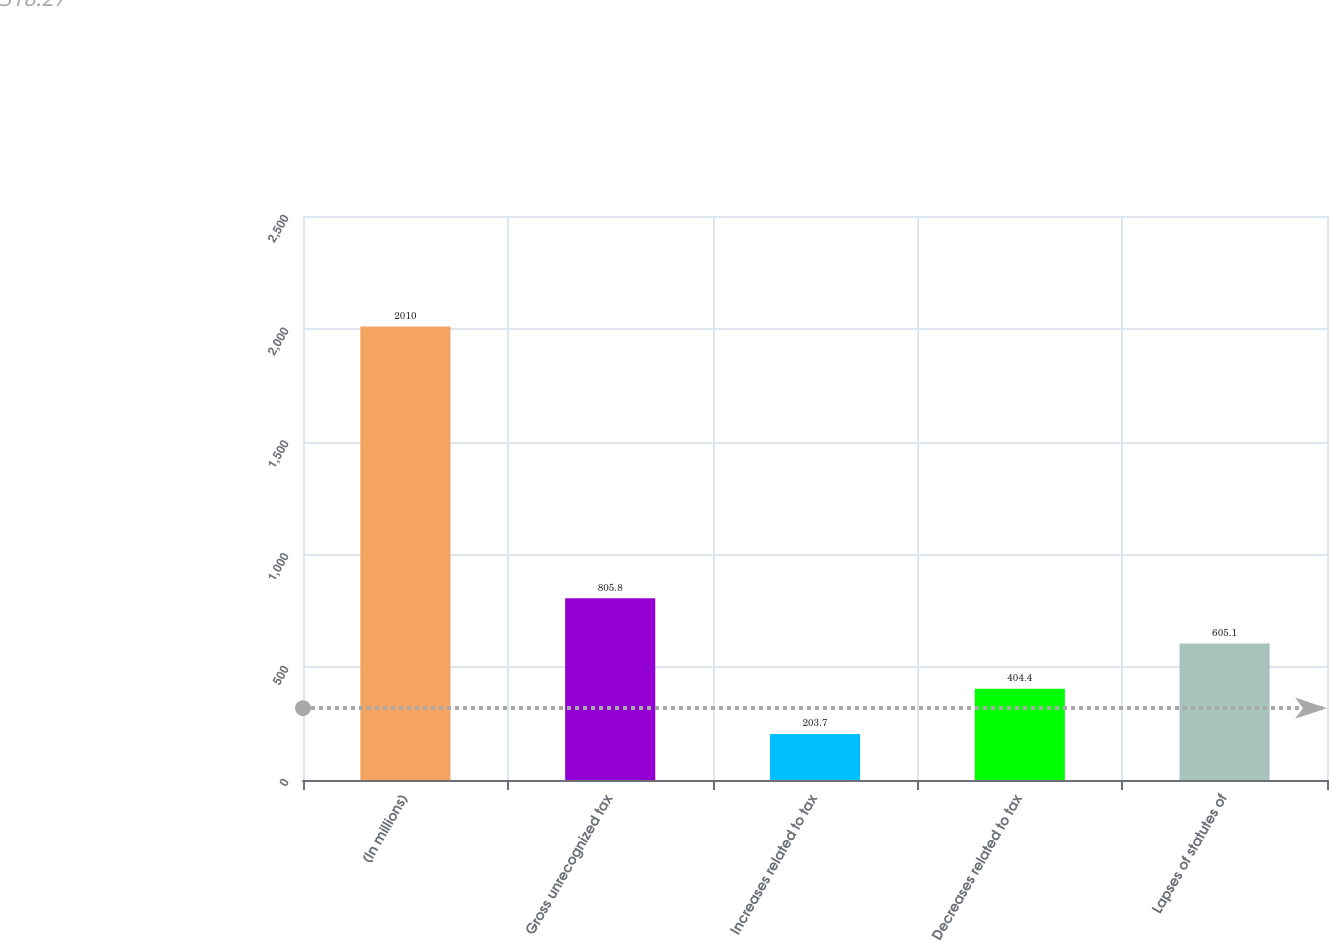Convert chart to OTSL. <chart><loc_0><loc_0><loc_500><loc_500><bar_chart><fcel>(In millions)<fcel>Gross unrecognized tax<fcel>Increases related to tax<fcel>Decreases related to tax<fcel>Lapses of statutes of<nl><fcel>2010<fcel>805.8<fcel>203.7<fcel>404.4<fcel>605.1<nl></chart> 